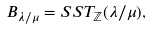Convert formula to latex. <formula><loc_0><loc_0><loc_500><loc_500>\ B _ { \lambda / \mu } = S S T _ { \mathbb { Z } } ( \lambda / \mu ) ,</formula> 